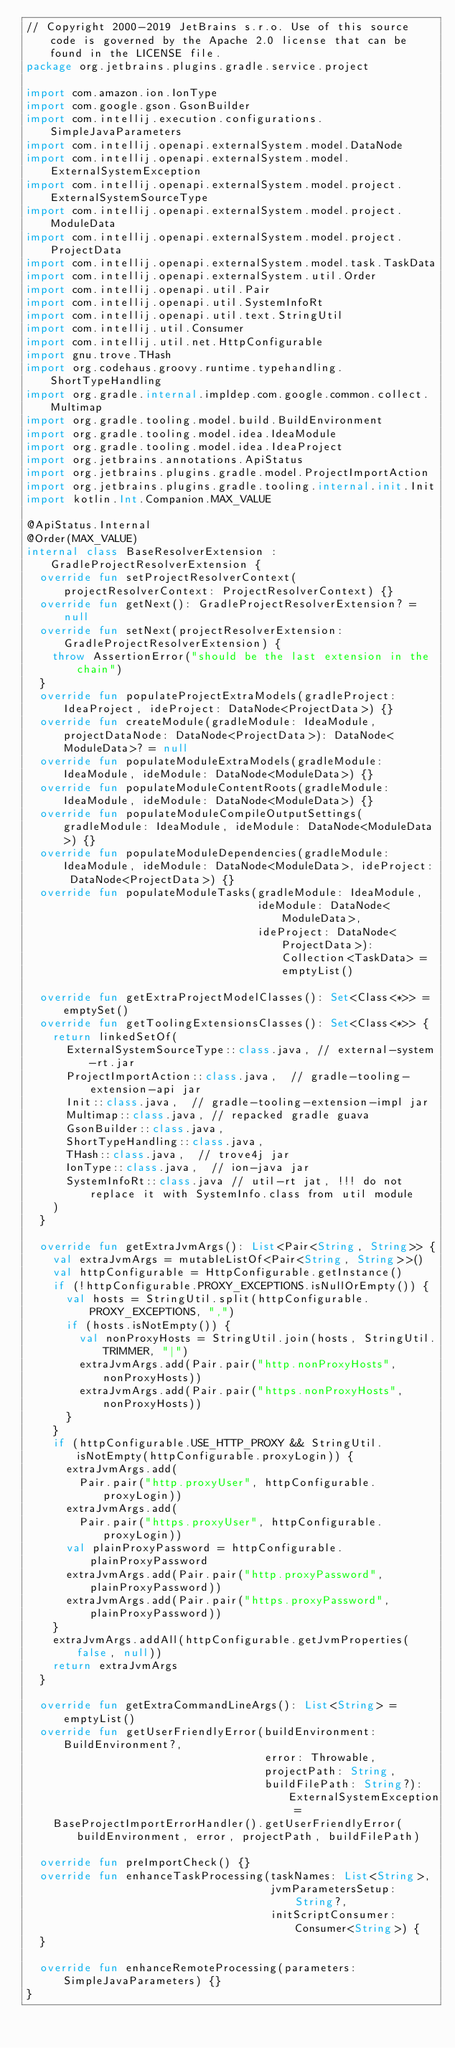Convert code to text. <code><loc_0><loc_0><loc_500><loc_500><_Kotlin_>// Copyright 2000-2019 JetBrains s.r.o. Use of this source code is governed by the Apache 2.0 license that can be found in the LICENSE file.
package org.jetbrains.plugins.gradle.service.project

import com.amazon.ion.IonType
import com.google.gson.GsonBuilder
import com.intellij.execution.configurations.SimpleJavaParameters
import com.intellij.openapi.externalSystem.model.DataNode
import com.intellij.openapi.externalSystem.model.ExternalSystemException
import com.intellij.openapi.externalSystem.model.project.ExternalSystemSourceType
import com.intellij.openapi.externalSystem.model.project.ModuleData
import com.intellij.openapi.externalSystem.model.project.ProjectData
import com.intellij.openapi.externalSystem.model.task.TaskData
import com.intellij.openapi.externalSystem.util.Order
import com.intellij.openapi.util.Pair
import com.intellij.openapi.util.SystemInfoRt
import com.intellij.openapi.util.text.StringUtil
import com.intellij.util.Consumer
import com.intellij.util.net.HttpConfigurable
import gnu.trove.THash
import org.codehaus.groovy.runtime.typehandling.ShortTypeHandling
import org.gradle.internal.impldep.com.google.common.collect.Multimap
import org.gradle.tooling.model.build.BuildEnvironment
import org.gradle.tooling.model.idea.IdeaModule
import org.gradle.tooling.model.idea.IdeaProject
import org.jetbrains.annotations.ApiStatus
import org.jetbrains.plugins.gradle.model.ProjectImportAction
import org.jetbrains.plugins.gradle.tooling.internal.init.Init
import kotlin.Int.Companion.MAX_VALUE

@ApiStatus.Internal
@Order(MAX_VALUE)
internal class BaseResolverExtension : GradleProjectResolverExtension {
  override fun setProjectResolverContext(projectResolverContext: ProjectResolverContext) {}
  override fun getNext(): GradleProjectResolverExtension? = null
  override fun setNext(projectResolverExtension: GradleProjectResolverExtension) {
    throw AssertionError("should be the last extension in the chain")
  }
  override fun populateProjectExtraModels(gradleProject: IdeaProject, ideProject: DataNode<ProjectData>) {}
  override fun createModule(gradleModule: IdeaModule, projectDataNode: DataNode<ProjectData>): DataNode<ModuleData>? = null
  override fun populateModuleExtraModels(gradleModule: IdeaModule, ideModule: DataNode<ModuleData>) {}
  override fun populateModuleContentRoots(gradleModule: IdeaModule, ideModule: DataNode<ModuleData>) {}
  override fun populateModuleCompileOutputSettings(gradleModule: IdeaModule, ideModule: DataNode<ModuleData>) {}
  override fun populateModuleDependencies(gradleModule: IdeaModule, ideModule: DataNode<ModuleData>, ideProject: DataNode<ProjectData>) {}
  override fun populateModuleTasks(gradleModule: IdeaModule,
                                   ideModule: DataNode<ModuleData>,
                                   ideProject: DataNode<ProjectData>): Collection<TaskData> = emptyList()

  override fun getExtraProjectModelClasses(): Set<Class<*>> = emptySet()
  override fun getToolingExtensionsClasses(): Set<Class<*>> {
    return linkedSetOf(
      ExternalSystemSourceType::class.java, // external-system-rt.jar
      ProjectImportAction::class.java,  // gradle-tooling-extension-api jar
      Init::class.java,  // gradle-tooling-extension-impl jar
      Multimap::class.java, // repacked gradle guava
      GsonBuilder::class.java,
      ShortTypeHandling::class.java,
      THash::class.java,  // trove4j jar
      IonType::class.java,  // ion-java jar
      SystemInfoRt::class.java // util-rt jat, !!! do not replace it with SystemInfo.class from util module
    )
  }

  override fun getExtraJvmArgs(): List<Pair<String, String>> {
    val extraJvmArgs = mutableListOf<Pair<String, String>>()
    val httpConfigurable = HttpConfigurable.getInstance()
    if (!httpConfigurable.PROXY_EXCEPTIONS.isNullOrEmpty()) {
      val hosts = StringUtil.split(httpConfigurable.PROXY_EXCEPTIONS, ",")
      if (hosts.isNotEmpty()) {
        val nonProxyHosts = StringUtil.join(hosts, StringUtil.TRIMMER, "|")
        extraJvmArgs.add(Pair.pair("http.nonProxyHosts", nonProxyHosts))
        extraJvmArgs.add(Pair.pair("https.nonProxyHosts", nonProxyHosts))
      }
    }
    if (httpConfigurable.USE_HTTP_PROXY && StringUtil.isNotEmpty(httpConfigurable.proxyLogin)) {
      extraJvmArgs.add(
        Pair.pair("http.proxyUser", httpConfigurable.proxyLogin))
      extraJvmArgs.add(
        Pair.pair("https.proxyUser", httpConfigurable.proxyLogin))
      val plainProxyPassword = httpConfigurable.plainProxyPassword
      extraJvmArgs.add(Pair.pair("http.proxyPassword", plainProxyPassword))
      extraJvmArgs.add(Pair.pair("https.proxyPassword", plainProxyPassword))
    }
    extraJvmArgs.addAll(httpConfigurable.getJvmProperties(false, null))
    return extraJvmArgs
  }

  override fun getExtraCommandLineArgs(): List<String> = emptyList()
  override fun getUserFriendlyError(buildEnvironment: BuildEnvironment?,
                                    error: Throwable,
                                    projectPath: String,
                                    buildFilePath: String?): ExternalSystemException =
    BaseProjectImportErrorHandler().getUserFriendlyError(buildEnvironment, error, projectPath, buildFilePath)

  override fun preImportCheck() {}
  override fun enhanceTaskProcessing(taskNames: List<String>,
                                     jvmParametersSetup: String?,
                                     initScriptConsumer: Consumer<String>) {
  }

  override fun enhanceRemoteProcessing(parameters: SimpleJavaParameters) {}
}</code> 